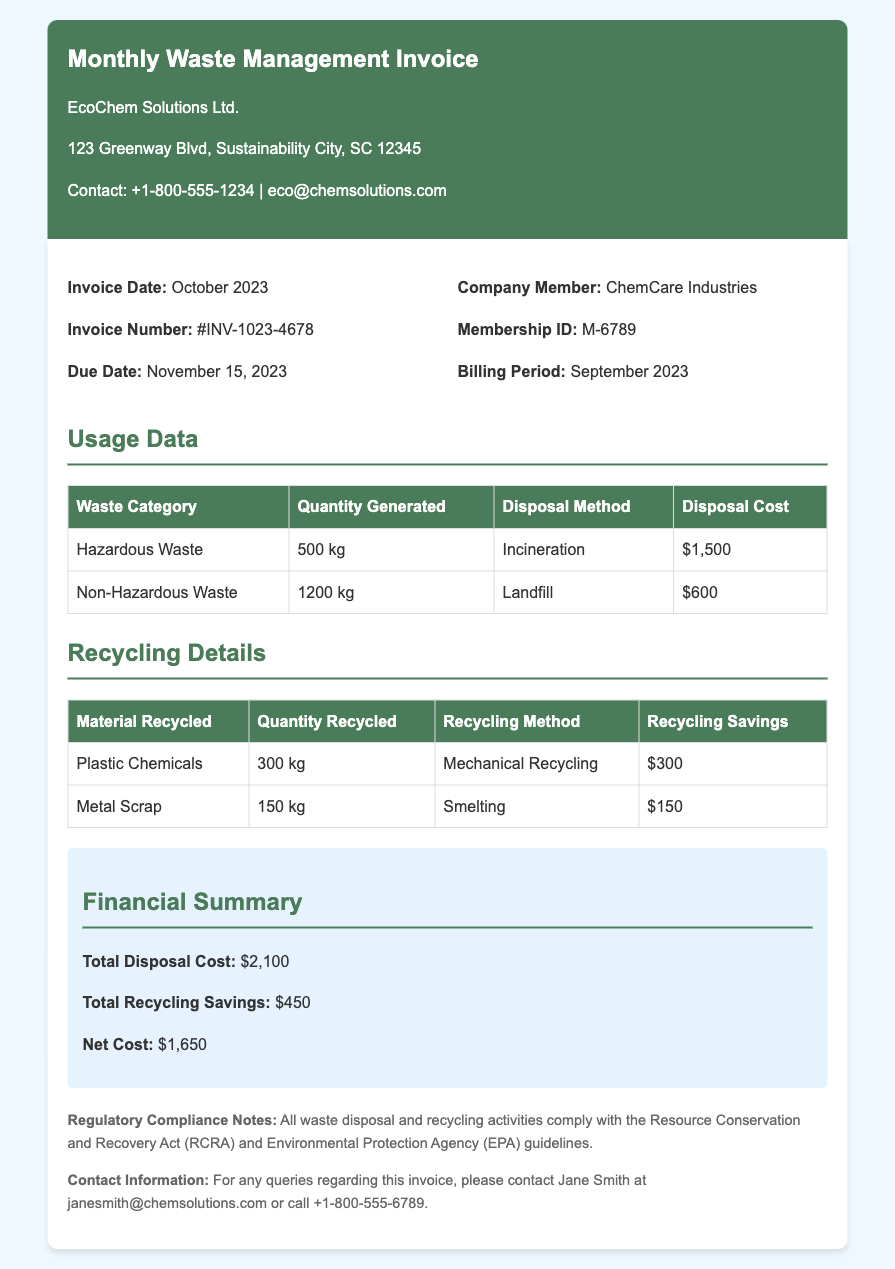What is the invoice date? The invoice date is clearly indicated in the document as the date on which the invoice was issued.
Answer: October 2023 What is the invoice number? The invoice number is provided in the document, typically used for tracking purposes.
Answer: #INV-1023-4678 What is the due date? The due date is specified in the document as the last date for payment.
Answer: November 15, 2023 How much hazardous waste was generated? The quantity of hazardous waste generated is stated directly in the usage data table.
Answer: 500 kg What is the total disposal cost? The total disposal cost is summarized in the financial section of the document.
Answer: $2,100 What is the total recycling savings? The total recycling savings is displayed in the financial summary section.
Answer: $450 What recycling method was used for plastic chemicals? The document outlines the recycling method utilized for each material in the recycling details section.
Answer: Mechanical Recycling What is the membership ID for ChemCare Industries? The membership ID is listed in the section providing company member details.
Answer: M-6789 What regulatory compliance act is mentioned? The document refers to a specific act that governs waste management compliance.
Answer: Resource Conservation and Recovery Act (RCRA) 